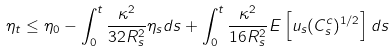<formula> <loc_0><loc_0><loc_500><loc_500>\eta _ { t } \leq \eta _ { 0 } - \int _ { 0 } ^ { t } \frac { \kappa ^ { 2 } } { 3 2 R _ { s } ^ { 2 } } \eta _ { s } d s + \int ^ { t } _ { 0 } \frac { \kappa ^ { 2 } } { 1 6 R _ { s } ^ { 2 } } E \left [ u _ { s } ( C _ { s } ^ { c } ) ^ { 1 / 2 } \right ] d s</formula> 